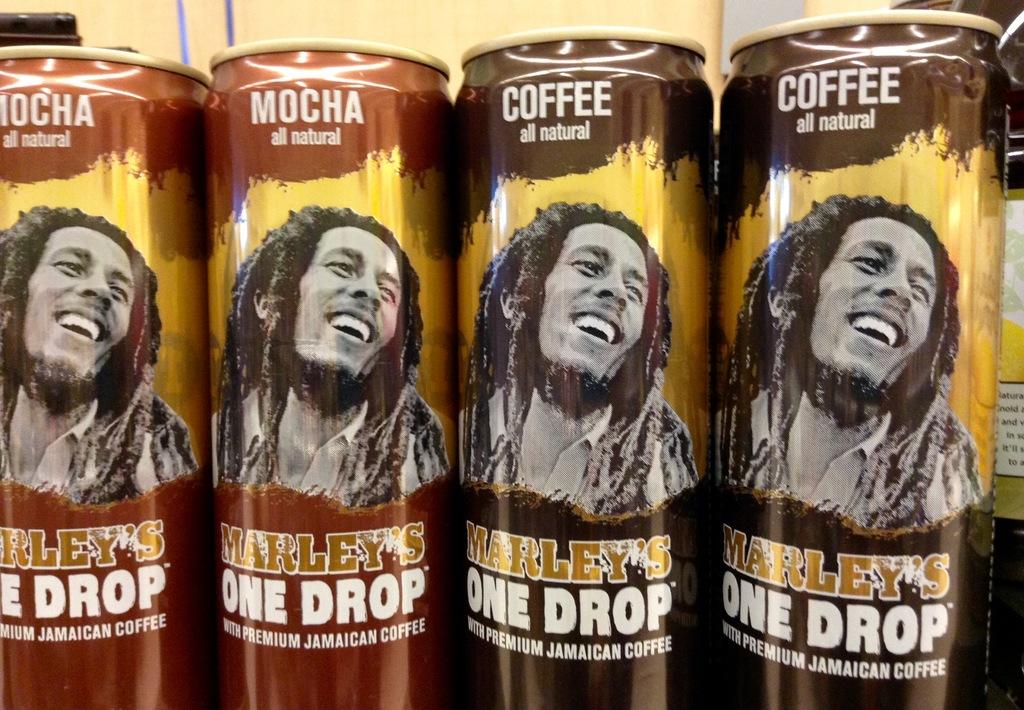Who's name is on the front?
Offer a terse response. Marley. 